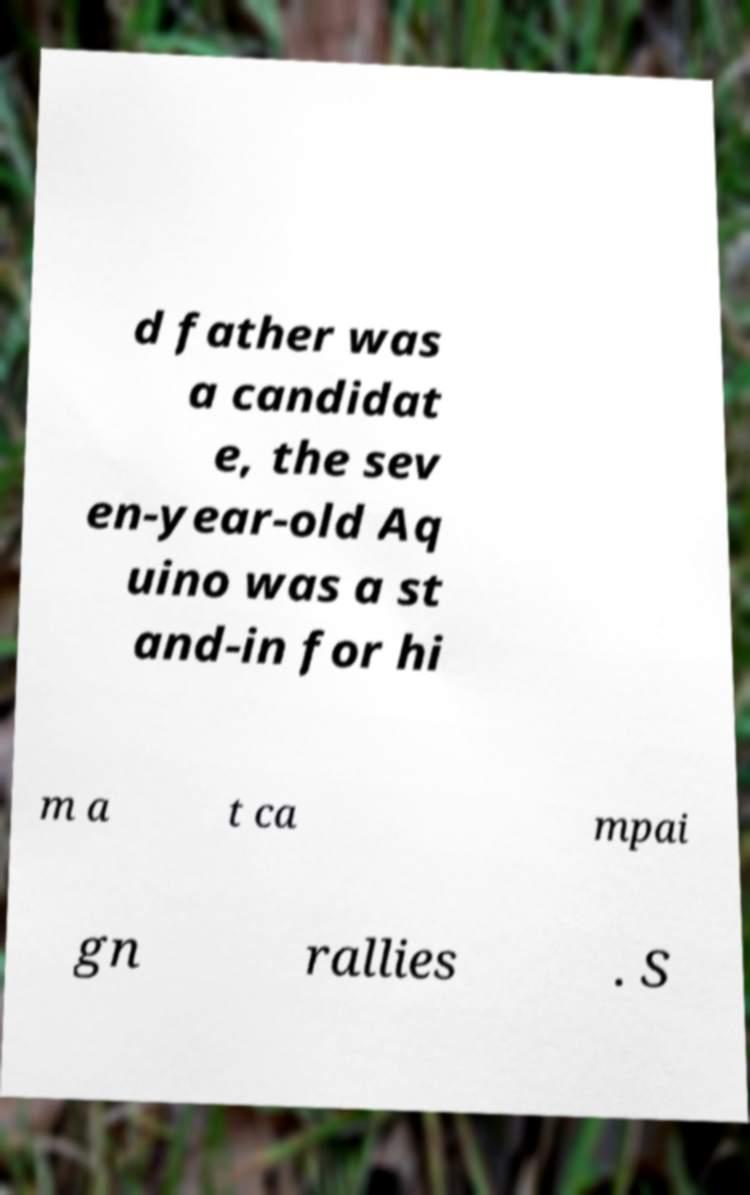There's text embedded in this image that I need extracted. Can you transcribe it verbatim? d father was a candidat e, the sev en-year-old Aq uino was a st and-in for hi m a t ca mpai gn rallies . S 